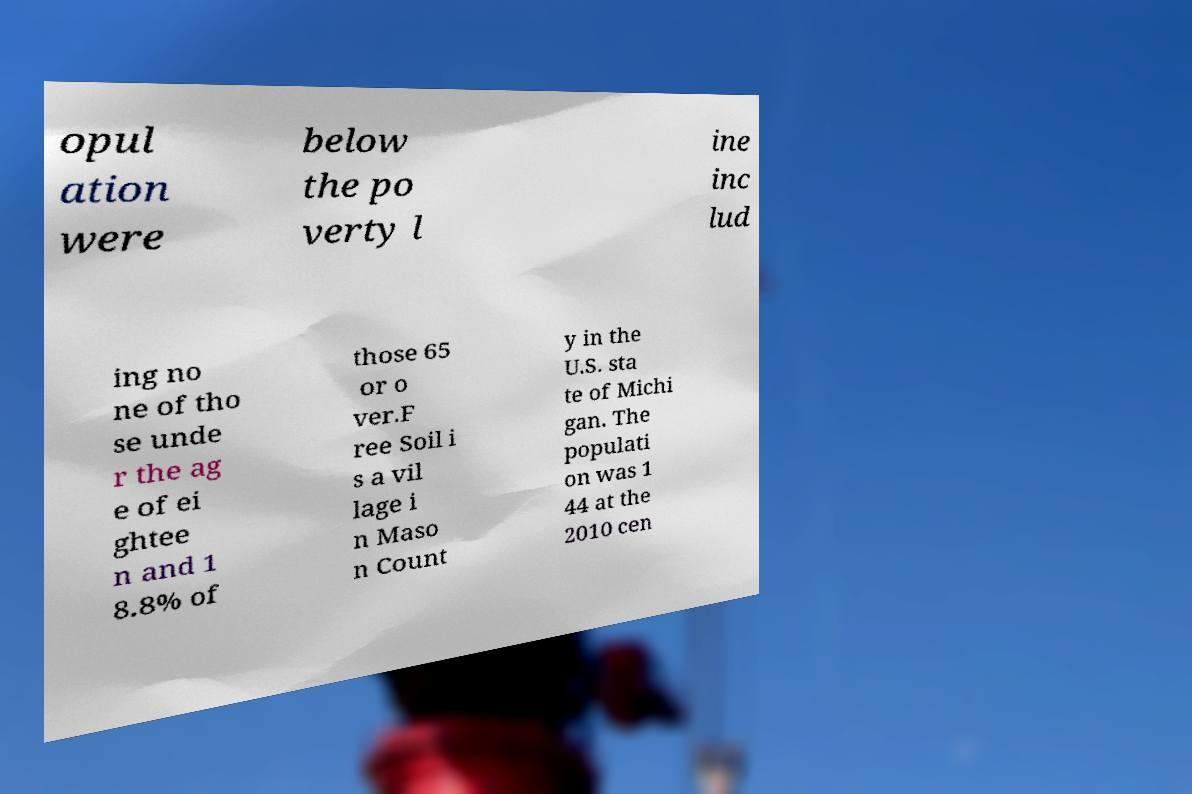Could you assist in decoding the text presented in this image and type it out clearly? opul ation were below the po verty l ine inc lud ing no ne of tho se unde r the ag e of ei ghtee n and 1 8.8% of those 65 or o ver.F ree Soil i s a vil lage i n Maso n Count y in the U.S. sta te of Michi gan. The populati on was 1 44 at the 2010 cen 